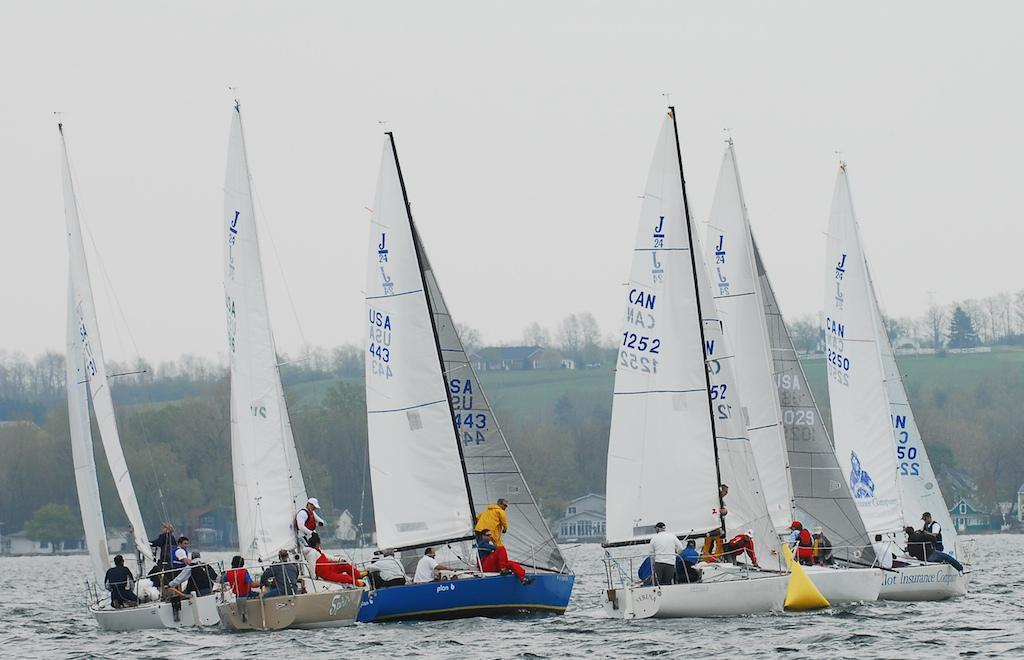<image>
Summarize the visual content of the image. Several sailboats, the closest of which says CAN 1252 on the sail. 